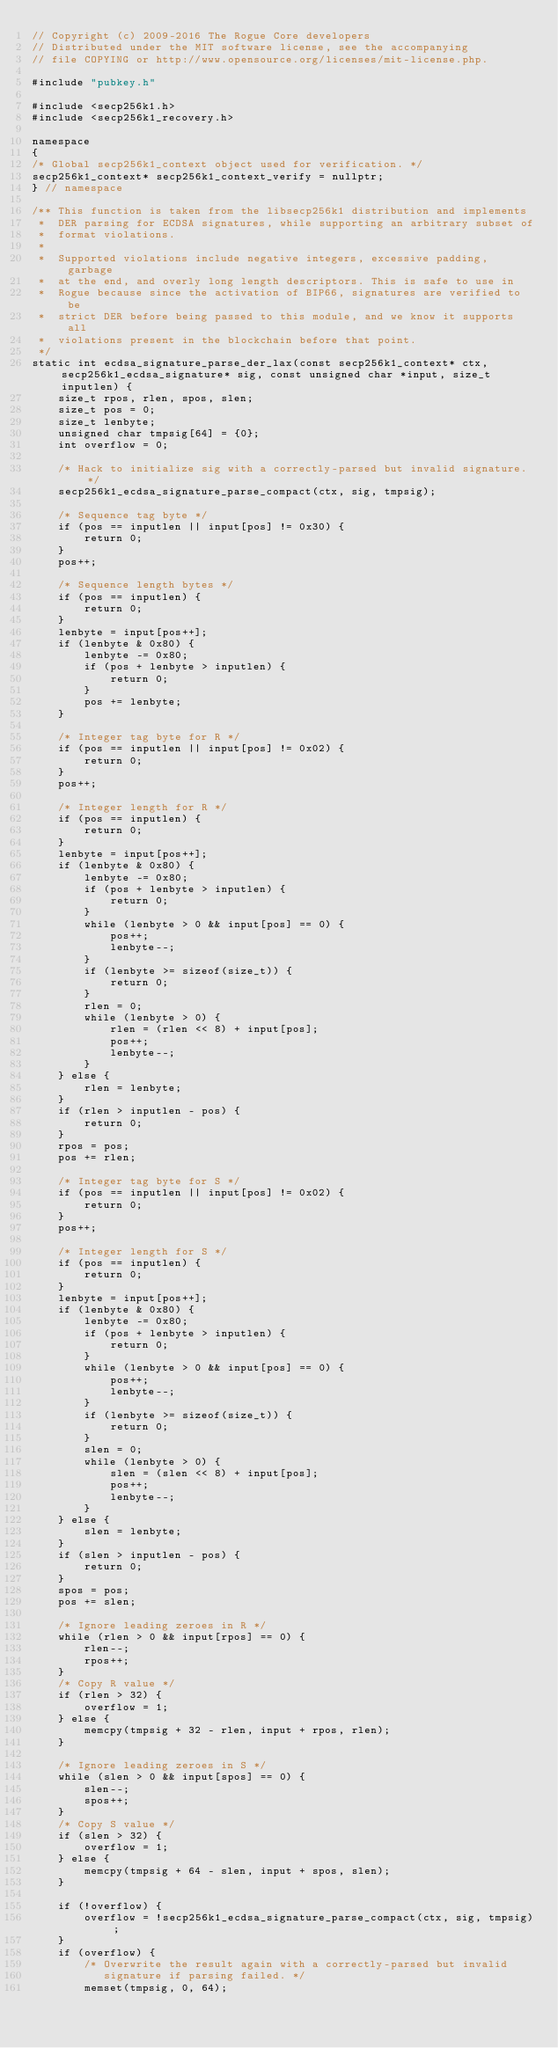Convert code to text. <code><loc_0><loc_0><loc_500><loc_500><_C++_>// Copyright (c) 2009-2016 The Rogue Core developers
// Distributed under the MIT software license, see the accompanying
// file COPYING or http://www.opensource.org/licenses/mit-license.php.

#include "pubkey.h"

#include <secp256k1.h>
#include <secp256k1_recovery.h>

namespace
{
/* Global secp256k1_context object used for verification. */
secp256k1_context* secp256k1_context_verify = nullptr;
} // namespace

/** This function is taken from the libsecp256k1 distribution and implements
 *  DER parsing for ECDSA signatures, while supporting an arbitrary subset of
 *  format violations.
 *
 *  Supported violations include negative integers, excessive padding, garbage
 *  at the end, and overly long length descriptors. This is safe to use in
 *  Rogue because since the activation of BIP66, signatures are verified to be
 *  strict DER before being passed to this module, and we know it supports all
 *  violations present in the blockchain before that point.
 */
static int ecdsa_signature_parse_der_lax(const secp256k1_context* ctx, secp256k1_ecdsa_signature* sig, const unsigned char *input, size_t inputlen) {
    size_t rpos, rlen, spos, slen;
    size_t pos = 0;
    size_t lenbyte;
    unsigned char tmpsig[64] = {0};
    int overflow = 0;

    /* Hack to initialize sig with a correctly-parsed but invalid signature. */
    secp256k1_ecdsa_signature_parse_compact(ctx, sig, tmpsig);

    /* Sequence tag byte */
    if (pos == inputlen || input[pos] != 0x30) {
        return 0;
    }
    pos++;

    /* Sequence length bytes */
    if (pos == inputlen) {
        return 0;
    }
    lenbyte = input[pos++];
    if (lenbyte & 0x80) {
        lenbyte -= 0x80;
        if (pos + lenbyte > inputlen) {
            return 0;
        }
        pos += lenbyte;
    }

    /* Integer tag byte for R */
    if (pos == inputlen || input[pos] != 0x02) {
        return 0;
    }
    pos++;

    /* Integer length for R */
    if (pos == inputlen) {
        return 0;
    }
    lenbyte = input[pos++];
    if (lenbyte & 0x80) {
        lenbyte -= 0x80;
        if (pos + lenbyte > inputlen) {
            return 0;
        }
        while (lenbyte > 0 && input[pos] == 0) {
            pos++;
            lenbyte--;
        }
        if (lenbyte >= sizeof(size_t)) {
            return 0;
        }
        rlen = 0;
        while (lenbyte > 0) {
            rlen = (rlen << 8) + input[pos];
            pos++;
            lenbyte--;
        }
    } else {
        rlen = lenbyte;
    }
    if (rlen > inputlen - pos) {
        return 0;
    }
    rpos = pos;
    pos += rlen;

    /* Integer tag byte for S */
    if (pos == inputlen || input[pos] != 0x02) {
        return 0;
    }
    pos++;

    /* Integer length for S */
    if (pos == inputlen) {
        return 0;
    }
    lenbyte = input[pos++];
    if (lenbyte & 0x80) {
        lenbyte -= 0x80;
        if (pos + lenbyte > inputlen) {
            return 0;
        }
        while (lenbyte > 0 && input[pos] == 0) {
            pos++;
            lenbyte--;
        }
        if (lenbyte >= sizeof(size_t)) {
            return 0;
        }
        slen = 0;
        while (lenbyte > 0) {
            slen = (slen << 8) + input[pos];
            pos++;
            lenbyte--;
        }
    } else {
        slen = lenbyte;
    }
    if (slen > inputlen - pos) {
        return 0;
    }
    spos = pos;
    pos += slen;

    /* Ignore leading zeroes in R */
    while (rlen > 0 && input[rpos] == 0) {
        rlen--;
        rpos++;
    }
    /* Copy R value */
    if (rlen > 32) {
        overflow = 1;
    } else {
        memcpy(tmpsig + 32 - rlen, input + rpos, rlen);
    }

    /* Ignore leading zeroes in S */
    while (slen > 0 && input[spos] == 0) {
        slen--;
        spos++;
    }
    /* Copy S value */
    if (slen > 32) {
        overflow = 1;
    } else {
        memcpy(tmpsig + 64 - slen, input + spos, slen);
    }

    if (!overflow) {
        overflow = !secp256k1_ecdsa_signature_parse_compact(ctx, sig, tmpsig);
    }
    if (overflow) {
        /* Overwrite the result again with a correctly-parsed but invalid
           signature if parsing failed. */
        memset(tmpsig, 0, 64);</code> 